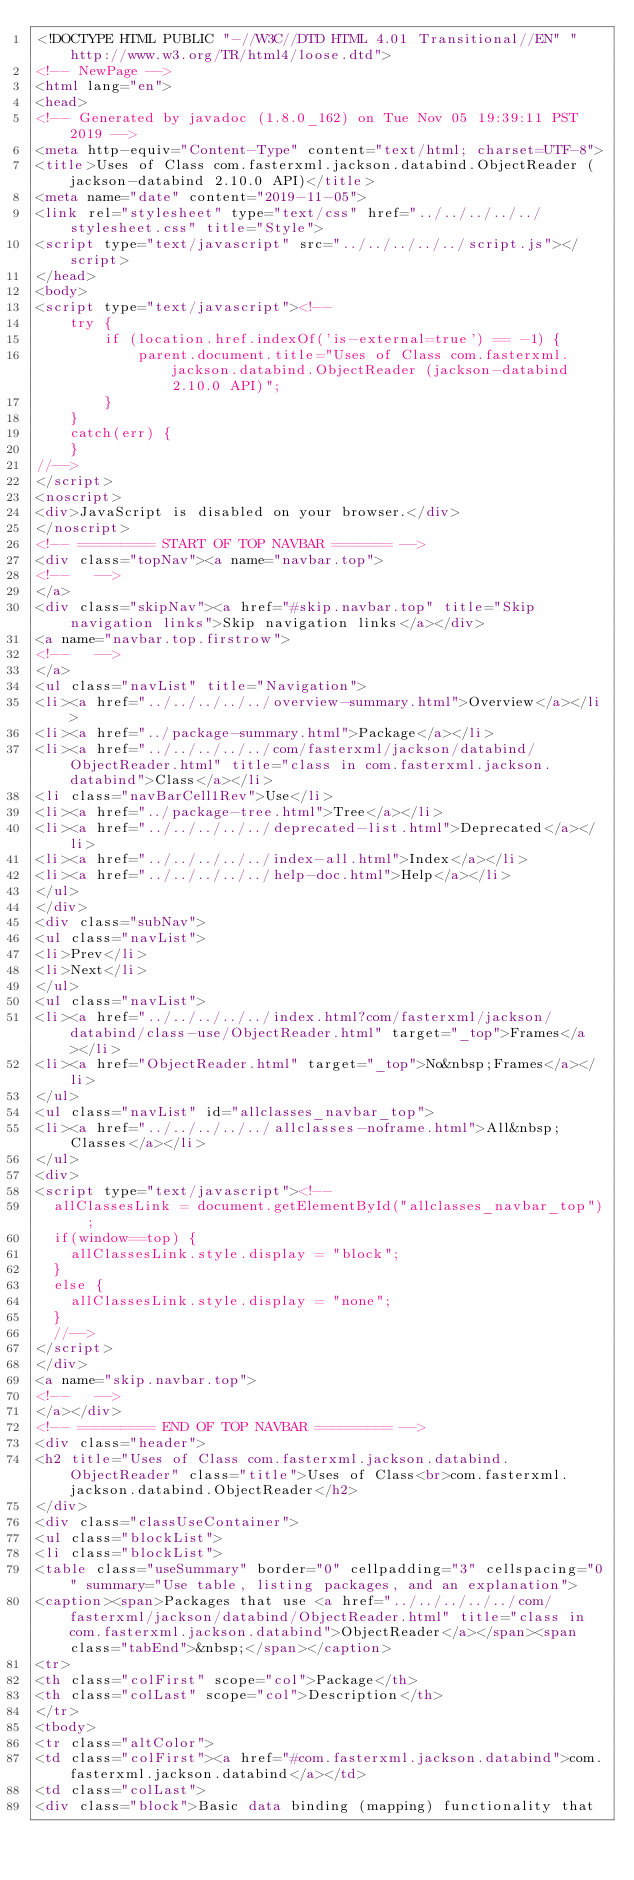<code> <loc_0><loc_0><loc_500><loc_500><_HTML_><!DOCTYPE HTML PUBLIC "-//W3C//DTD HTML 4.01 Transitional//EN" "http://www.w3.org/TR/html4/loose.dtd">
<!-- NewPage -->
<html lang="en">
<head>
<!-- Generated by javadoc (1.8.0_162) on Tue Nov 05 19:39:11 PST 2019 -->
<meta http-equiv="Content-Type" content="text/html; charset=UTF-8">
<title>Uses of Class com.fasterxml.jackson.databind.ObjectReader (jackson-databind 2.10.0 API)</title>
<meta name="date" content="2019-11-05">
<link rel="stylesheet" type="text/css" href="../../../../../stylesheet.css" title="Style">
<script type="text/javascript" src="../../../../../script.js"></script>
</head>
<body>
<script type="text/javascript"><!--
    try {
        if (location.href.indexOf('is-external=true') == -1) {
            parent.document.title="Uses of Class com.fasterxml.jackson.databind.ObjectReader (jackson-databind 2.10.0 API)";
        }
    }
    catch(err) {
    }
//-->
</script>
<noscript>
<div>JavaScript is disabled on your browser.</div>
</noscript>
<!-- ========= START OF TOP NAVBAR ======= -->
<div class="topNav"><a name="navbar.top">
<!--   -->
</a>
<div class="skipNav"><a href="#skip.navbar.top" title="Skip navigation links">Skip navigation links</a></div>
<a name="navbar.top.firstrow">
<!--   -->
</a>
<ul class="navList" title="Navigation">
<li><a href="../../../../../overview-summary.html">Overview</a></li>
<li><a href="../package-summary.html">Package</a></li>
<li><a href="../../../../../com/fasterxml/jackson/databind/ObjectReader.html" title="class in com.fasterxml.jackson.databind">Class</a></li>
<li class="navBarCell1Rev">Use</li>
<li><a href="../package-tree.html">Tree</a></li>
<li><a href="../../../../../deprecated-list.html">Deprecated</a></li>
<li><a href="../../../../../index-all.html">Index</a></li>
<li><a href="../../../../../help-doc.html">Help</a></li>
</ul>
</div>
<div class="subNav">
<ul class="navList">
<li>Prev</li>
<li>Next</li>
</ul>
<ul class="navList">
<li><a href="../../../../../index.html?com/fasterxml/jackson/databind/class-use/ObjectReader.html" target="_top">Frames</a></li>
<li><a href="ObjectReader.html" target="_top">No&nbsp;Frames</a></li>
</ul>
<ul class="navList" id="allclasses_navbar_top">
<li><a href="../../../../../allclasses-noframe.html">All&nbsp;Classes</a></li>
</ul>
<div>
<script type="text/javascript"><!--
  allClassesLink = document.getElementById("allclasses_navbar_top");
  if(window==top) {
    allClassesLink.style.display = "block";
  }
  else {
    allClassesLink.style.display = "none";
  }
  //-->
</script>
</div>
<a name="skip.navbar.top">
<!--   -->
</a></div>
<!-- ========= END OF TOP NAVBAR ========= -->
<div class="header">
<h2 title="Uses of Class com.fasterxml.jackson.databind.ObjectReader" class="title">Uses of Class<br>com.fasterxml.jackson.databind.ObjectReader</h2>
</div>
<div class="classUseContainer">
<ul class="blockList">
<li class="blockList">
<table class="useSummary" border="0" cellpadding="3" cellspacing="0" summary="Use table, listing packages, and an explanation">
<caption><span>Packages that use <a href="../../../../../com/fasterxml/jackson/databind/ObjectReader.html" title="class in com.fasterxml.jackson.databind">ObjectReader</a></span><span class="tabEnd">&nbsp;</span></caption>
<tr>
<th class="colFirst" scope="col">Package</th>
<th class="colLast" scope="col">Description</th>
</tr>
<tbody>
<tr class="altColor">
<td class="colFirst"><a href="#com.fasterxml.jackson.databind">com.fasterxml.jackson.databind</a></td>
<td class="colLast">
<div class="block">Basic data binding (mapping) functionality that</code> 